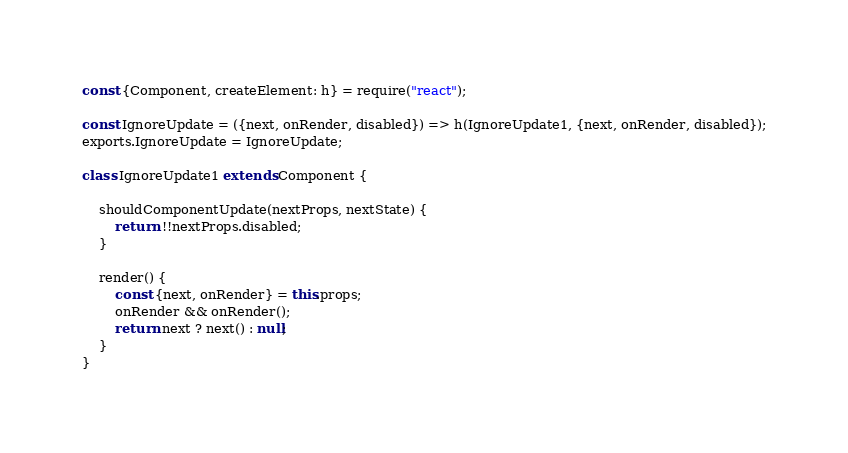<code> <loc_0><loc_0><loc_500><loc_500><_JavaScript_>const {Component, createElement: h} = require("react");

const IgnoreUpdate = ({next, onRender, disabled}) => h(IgnoreUpdate1, {next, onRender, disabled});
exports.IgnoreUpdate = IgnoreUpdate;

class IgnoreUpdate1 extends Component {

    shouldComponentUpdate(nextProps, nextState) {
        return !!nextProps.disabled;
    }

    render() {
        const {next, onRender} = this.props;
        onRender && onRender();
        return next ? next() : null;
    }
}
</code> 